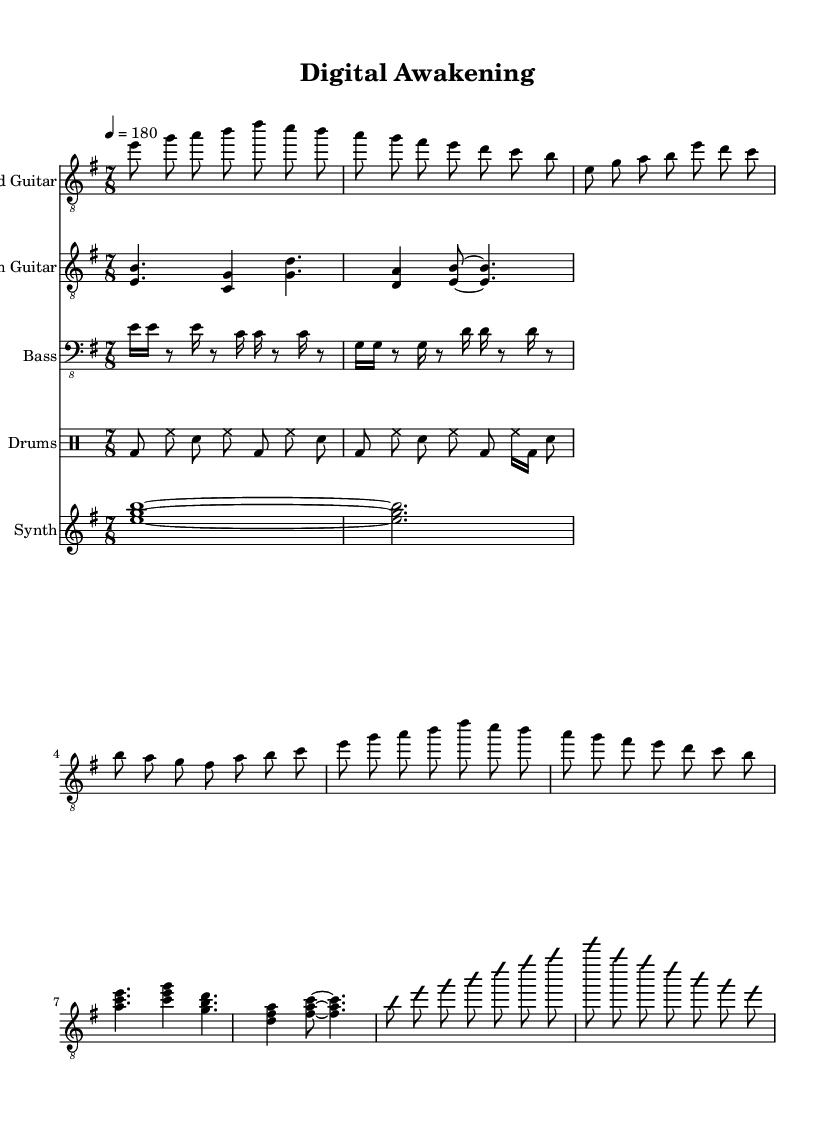What is the key signature of this music? The key signature indicated in the music is E minor, which has one sharp (F sharp). You can identify this by looking at the key signature notation at the beginning of the staff.
Answer: E minor What is the time signature of this piece? The time signature shown is 7/8, which means there are seven beats in a measure and the eighth note gets one beat. This is visibly placed at the beginning of the notation.
Answer: 7/8 What is the tempo marking in this score? The tempo marking is set at 180 beats per minute, as indicated near the beginning of the score by the tempo directive. It specifies how fast the piece should be played.
Answer: 180 Which instrument plays the lead guitar part? The lead guitar part is specifically notated in the score with the instrument name labeled as "Lead Guitar" in the staff. You can find this label at the start of the lead guitar staff line.
Answer: Lead Guitar How many different instrument parts are included in this score? There are five instrument parts included: Lead Guitar, Rhythm Guitar, Bass, Drums, and Synth. This can be identified by checking the different staves and their respective instrument names listed above each one.
Answer: Five What is the rhythmic pattern of the bass guitar? The bass guitar part showcases a syncopated pattern illustrated by the various notes and rests, which include rapid passages and rests creating a unique rhythmic texture. Analyzing the notation on the bass staff reveals variations in note values and rests across measures.
Answer: Syncopated What themes are explored in this piece according to its title? The title "Digital Awakening" suggests themes related to artificial intelligence and technological singularity, reflecting a progressive metal exploration of technology and its implications. The title itself gives insight into the thematic focus of the piece.
Answer: Artificial intelligence 